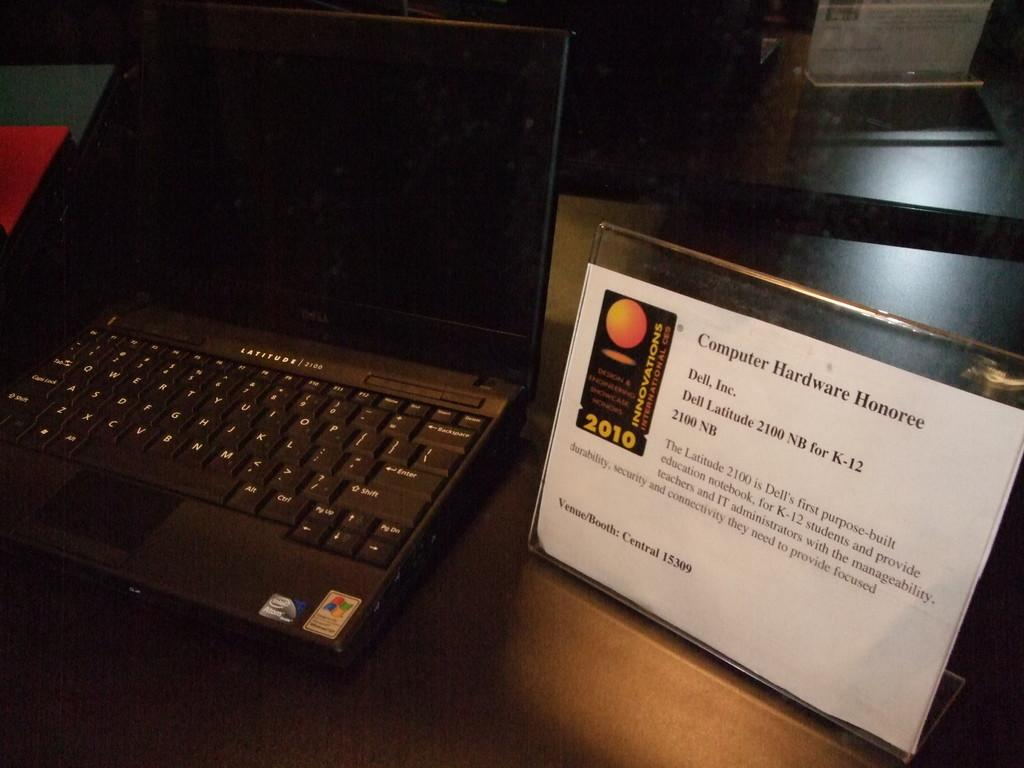<image>
Summarize the visual content of the image. An award sits beside a laptop for a computer hardware Honoree in 2010. 